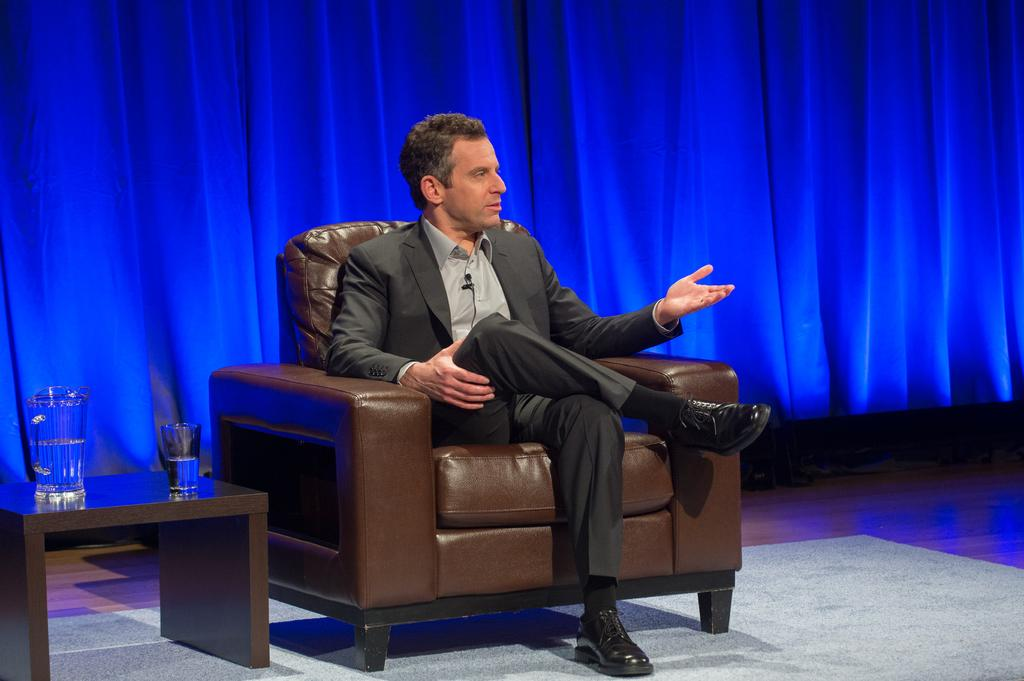What is the man in the image wearing? The man is wearing a suit. What is the man doing in the image? The man is sitting on a brown couch. What objects can be seen on the table in the image? There is a jar with water and a glass of water on the table. What color is the curtain in the background? The curtain in the background is blue. What type of flooring is present in the image? The floor has a carpet. What type of linen is being discussed on the news channel in the image? There is no television or news channel present in the image, so it is not possible to determine what type of linen is being discussed. 